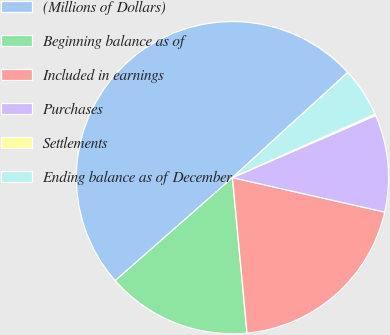Convert chart. <chart><loc_0><loc_0><loc_500><loc_500><pie_chart><fcel>(Millions of Dollars)<fcel>Beginning balance as of<fcel>Included in earnings<fcel>Purchases<fcel>Settlements<fcel>Ending balance as of December<nl><fcel>49.7%<fcel>15.01%<fcel>19.97%<fcel>10.06%<fcel>0.15%<fcel>5.1%<nl></chart> 